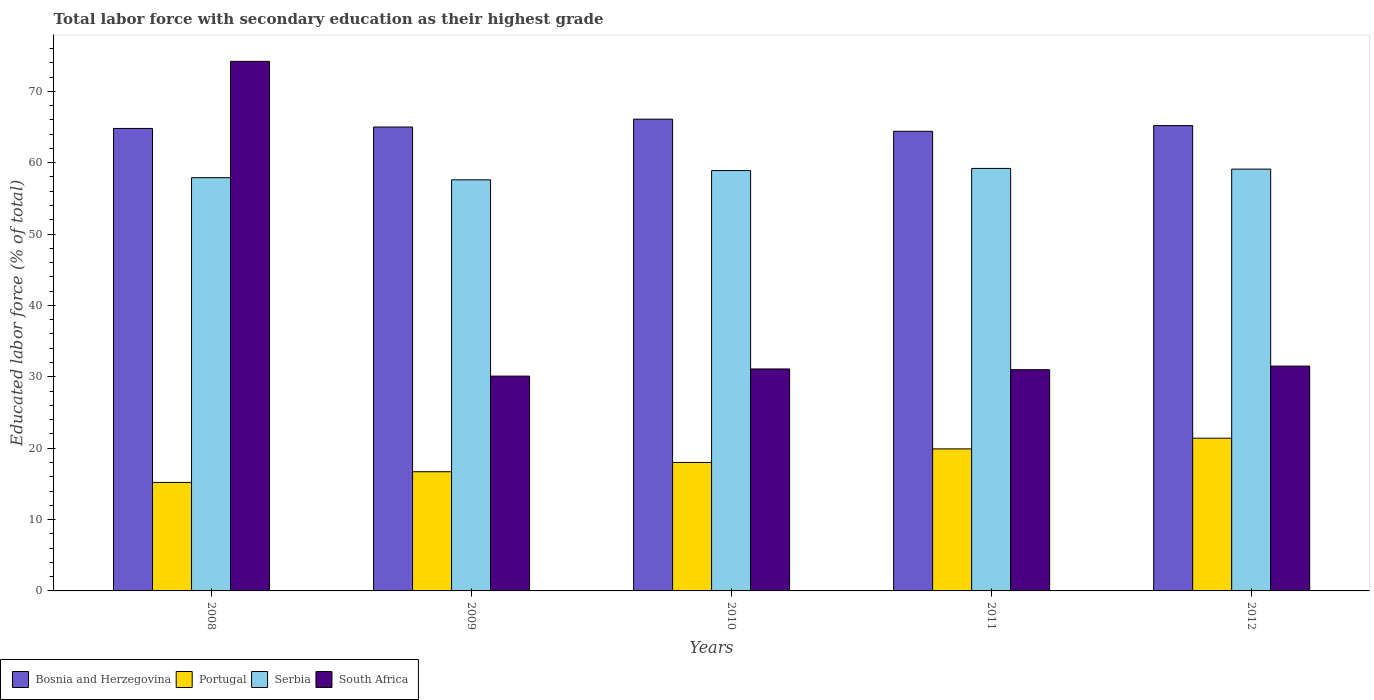Are the number of bars per tick equal to the number of legend labels?
Offer a terse response. Yes. How many bars are there on the 5th tick from the right?
Your response must be concise. 4. What is the percentage of total labor force with primary education in Bosnia and Herzegovina in 2009?
Make the answer very short. 65. Across all years, what is the maximum percentage of total labor force with primary education in Bosnia and Herzegovina?
Offer a very short reply. 66.1. Across all years, what is the minimum percentage of total labor force with primary education in South Africa?
Your answer should be very brief. 30.1. In which year was the percentage of total labor force with primary education in Bosnia and Herzegovina maximum?
Provide a short and direct response. 2010. In which year was the percentage of total labor force with primary education in Portugal minimum?
Keep it short and to the point. 2008. What is the total percentage of total labor force with primary education in Bosnia and Herzegovina in the graph?
Give a very brief answer. 325.5. What is the difference between the percentage of total labor force with primary education in Serbia in 2010 and that in 2011?
Provide a short and direct response. -0.3. What is the difference between the percentage of total labor force with primary education in Serbia in 2011 and the percentage of total labor force with primary education in South Africa in 2012?
Offer a very short reply. 27.7. What is the average percentage of total labor force with primary education in South Africa per year?
Give a very brief answer. 39.58. In the year 2011, what is the difference between the percentage of total labor force with primary education in South Africa and percentage of total labor force with primary education in Bosnia and Herzegovina?
Make the answer very short. -33.4. In how many years, is the percentage of total labor force with primary education in Serbia greater than 64 %?
Your response must be concise. 0. What is the ratio of the percentage of total labor force with primary education in Portugal in 2008 to that in 2010?
Make the answer very short. 0.84. Is the difference between the percentage of total labor force with primary education in South Africa in 2011 and 2012 greater than the difference between the percentage of total labor force with primary education in Bosnia and Herzegovina in 2011 and 2012?
Offer a terse response. Yes. What is the difference between the highest and the second highest percentage of total labor force with primary education in Bosnia and Herzegovina?
Provide a succinct answer. 0.9. What is the difference between the highest and the lowest percentage of total labor force with primary education in Bosnia and Herzegovina?
Provide a succinct answer. 1.7. In how many years, is the percentage of total labor force with primary education in Portugal greater than the average percentage of total labor force with primary education in Portugal taken over all years?
Provide a succinct answer. 2. Is it the case that in every year, the sum of the percentage of total labor force with primary education in Serbia and percentage of total labor force with primary education in Bosnia and Herzegovina is greater than the sum of percentage of total labor force with primary education in Portugal and percentage of total labor force with primary education in South Africa?
Provide a short and direct response. No. What does the 1st bar from the left in 2009 represents?
Provide a short and direct response. Bosnia and Herzegovina. What does the 2nd bar from the right in 2012 represents?
Give a very brief answer. Serbia. How many bars are there?
Your response must be concise. 20. Are the values on the major ticks of Y-axis written in scientific E-notation?
Provide a succinct answer. No. Does the graph contain any zero values?
Give a very brief answer. No. How many legend labels are there?
Offer a terse response. 4. What is the title of the graph?
Make the answer very short. Total labor force with secondary education as their highest grade. What is the label or title of the Y-axis?
Provide a succinct answer. Educated labor force (% of total). What is the Educated labor force (% of total) in Bosnia and Herzegovina in 2008?
Offer a terse response. 64.8. What is the Educated labor force (% of total) in Portugal in 2008?
Offer a very short reply. 15.2. What is the Educated labor force (% of total) of Serbia in 2008?
Your response must be concise. 57.9. What is the Educated labor force (% of total) in South Africa in 2008?
Ensure brevity in your answer.  74.2. What is the Educated labor force (% of total) of Portugal in 2009?
Offer a very short reply. 16.7. What is the Educated labor force (% of total) in Serbia in 2009?
Offer a terse response. 57.6. What is the Educated labor force (% of total) of South Africa in 2009?
Keep it short and to the point. 30.1. What is the Educated labor force (% of total) in Bosnia and Herzegovina in 2010?
Provide a succinct answer. 66.1. What is the Educated labor force (% of total) in Portugal in 2010?
Your answer should be very brief. 18. What is the Educated labor force (% of total) of Serbia in 2010?
Provide a short and direct response. 58.9. What is the Educated labor force (% of total) in South Africa in 2010?
Offer a very short reply. 31.1. What is the Educated labor force (% of total) in Bosnia and Herzegovina in 2011?
Offer a very short reply. 64.4. What is the Educated labor force (% of total) of Portugal in 2011?
Provide a succinct answer. 19.9. What is the Educated labor force (% of total) in Serbia in 2011?
Your response must be concise. 59.2. What is the Educated labor force (% of total) in South Africa in 2011?
Your answer should be very brief. 31. What is the Educated labor force (% of total) of Bosnia and Herzegovina in 2012?
Give a very brief answer. 65.2. What is the Educated labor force (% of total) of Portugal in 2012?
Give a very brief answer. 21.4. What is the Educated labor force (% of total) in Serbia in 2012?
Keep it short and to the point. 59.1. What is the Educated labor force (% of total) in South Africa in 2012?
Keep it short and to the point. 31.5. Across all years, what is the maximum Educated labor force (% of total) of Bosnia and Herzegovina?
Keep it short and to the point. 66.1. Across all years, what is the maximum Educated labor force (% of total) in Portugal?
Offer a very short reply. 21.4. Across all years, what is the maximum Educated labor force (% of total) in Serbia?
Your response must be concise. 59.2. Across all years, what is the maximum Educated labor force (% of total) of South Africa?
Your response must be concise. 74.2. Across all years, what is the minimum Educated labor force (% of total) in Bosnia and Herzegovina?
Offer a terse response. 64.4. Across all years, what is the minimum Educated labor force (% of total) in Portugal?
Offer a very short reply. 15.2. Across all years, what is the minimum Educated labor force (% of total) in Serbia?
Give a very brief answer. 57.6. Across all years, what is the minimum Educated labor force (% of total) of South Africa?
Give a very brief answer. 30.1. What is the total Educated labor force (% of total) in Bosnia and Herzegovina in the graph?
Provide a succinct answer. 325.5. What is the total Educated labor force (% of total) of Portugal in the graph?
Make the answer very short. 91.2. What is the total Educated labor force (% of total) of Serbia in the graph?
Your answer should be compact. 292.7. What is the total Educated labor force (% of total) in South Africa in the graph?
Your response must be concise. 197.9. What is the difference between the Educated labor force (% of total) of Bosnia and Herzegovina in 2008 and that in 2009?
Give a very brief answer. -0.2. What is the difference between the Educated labor force (% of total) in South Africa in 2008 and that in 2009?
Make the answer very short. 44.1. What is the difference between the Educated labor force (% of total) of Serbia in 2008 and that in 2010?
Offer a very short reply. -1. What is the difference between the Educated labor force (% of total) in South Africa in 2008 and that in 2010?
Your response must be concise. 43.1. What is the difference between the Educated labor force (% of total) in Serbia in 2008 and that in 2011?
Keep it short and to the point. -1.3. What is the difference between the Educated labor force (% of total) in South Africa in 2008 and that in 2011?
Give a very brief answer. 43.2. What is the difference between the Educated labor force (% of total) of Bosnia and Herzegovina in 2008 and that in 2012?
Keep it short and to the point. -0.4. What is the difference between the Educated labor force (% of total) in Serbia in 2008 and that in 2012?
Your answer should be compact. -1.2. What is the difference between the Educated labor force (% of total) of South Africa in 2008 and that in 2012?
Offer a very short reply. 42.7. What is the difference between the Educated labor force (% of total) in Portugal in 2009 and that in 2010?
Ensure brevity in your answer.  -1.3. What is the difference between the Educated labor force (% of total) in Serbia in 2009 and that in 2010?
Your answer should be very brief. -1.3. What is the difference between the Educated labor force (% of total) of South Africa in 2009 and that in 2010?
Ensure brevity in your answer.  -1. What is the difference between the Educated labor force (% of total) of South Africa in 2009 and that in 2011?
Your response must be concise. -0.9. What is the difference between the Educated labor force (% of total) in South Africa in 2009 and that in 2012?
Make the answer very short. -1.4. What is the difference between the Educated labor force (% of total) in Portugal in 2010 and that in 2011?
Provide a succinct answer. -1.9. What is the difference between the Educated labor force (% of total) of Serbia in 2010 and that in 2011?
Your answer should be compact. -0.3. What is the difference between the Educated labor force (% of total) of South Africa in 2010 and that in 2011?
Offer a very short reply. 0.1. What is the difference between the Educated labor force (% of total) of Bosnia and Herzegovina in 2010 and that in 2012?
Give a very brief answer. 0.9. What is the difference between the Educated labor force (% of total) in Portugal in 2010 and that in 2012?
Keep it short and to the point. -3.4. What is the difference between the Educated labor force (% of total) of South Africa in 2010 and that in 2012?
Ensure brevity in your answer.  -0.4. What is the difference between the Educated labor force (% of total) in Bosnia and Herzegovina in 2011 and that in 2012?
Keep it short and to the point. -0.8. What is the difference between the Educated labor force (% of total) in South Africa in 2011 and that in 2012?
Give a very brief answer. -0.5. What is the difference between the Educated labor force (% of total) in Bosnia and Herzegovina in 2008 and the Educated labor force (% of total) in Portugal in 2009?
Offer a very short reply. 48.1. What is the difference between the Educated labor force (% of total) of Bosnia and Herzegovina in 2008 and the Educated labor force (% of total) of South Africa in 2009?
Your answer should be compact. 34.7. What is the difference between the Educated labor force (% of total) in Portugal in 2008 and the Educated labor force (% of total) in Serbia in 2009?
Ensure brevity in your answer.  -42.4. What is the difference between the Educated labor force (% of total) in Portugal in 2008 and the Educated labor force (% of total) in South Africa in 2009?
Ensure brevity in your answer.  -14.9. What is the difference between the Educated labor force (% of total) in Serbia in 2008 and the Educated labor force (% of total) in South Africa in 2009?
Give a very brief answer. 27.8. What is the difference between the Educated labor force (% of total) in Bosnia and Herzegovina in 2008 and the Educated labor force (% of total) in Portugal in 2010?
Your answer should be compact. 46.8. What is the difference between the Educated labor force (% of total) of Bosnia and Herzegovina in 2008 and the Educated labor force (% of total) of Serbia in 2010?
Provide a succinct answer. 5.9. What is the difference between the Educated labor force (% of total) in Bosnia and Herzegovina in 2008 and the Educated labor force (% of total) in South Africa in 2010?
Your response must be concise. 33.7. What is the difference between the Educated labor force (% of total) of Portugal in 2008 and the Educated labor force (% of total) of Serbia in 2010?
Provide a short and direct response. -43.7. What is the difference between the Educated labor force (% of total) of Portugal in 2008 and the Educated labor force (% of total) of South Africa in 2010?
Offer a terse response. -15.9. What is the difference between the Educated labor force (% of total) of Serbia in 2008 and the Educated labor force (% of total) of South Africa in 2010?
Give a very brief answer. 26.8. What is the difference between the Educated labor force (% of total) in Bosnia and Herzegovina in 2008 and the Educated labor force (% of total) in Portugal in 2011?
Ensure brevity in your answer.  44.9. What is the difference between the Educated labor force (% of total) in Bosnia and Herzegovina in 2008 and the Educated labor force (% of total) in South Africa in 2011?
Offer a very short reply. 33.8. What is the difference between the Educated labor force (% of total) of Portugal in 2008 and the Educated labor force (% of total) of Serbia in 2011?
Your answer should be compact. -44. What is the difference between the Educated labor force (% of total) in Portugal in 2008 and the Educated labor force (% of total) in South Africa in 2011?
Offer a very short reply. -15.8. What is the difference between the Educated labor force (% of total) of Serbia in 2008 and the Educated labor force (% of total) of South Africa in 2011?
Keep it short and to the point. 26.9. What is the difference between the Educated labor force (% of total) in Bosnia and Herzegovina in 2008 and the Educated labor force (% of total) in Portugal in 2012?
Offer a very short reply. 43.4. What is the difference between the Educated labor force (% of total) in Bosnia and Herzegovina in 2008 and the Educated labor force (% of total) in Serbia in 2012?
Offer a terse response. 5.7. What is the difference between the Educated labor force (% of total) in Bosnia and Herzegovina in 2008 and the Educated labor force (% of total) in South Africa in 2012?
Your answer should be very brief. 33.3. What is the difference between the Educated labor force (% of total) in Portugal in 2008 and the Educated labor force (% of total) in Serbia in 2012?
Your answer should be compact. -43.9. What is the difference between the Educated labor force (% of total) of Portugal in 2008 and the Educated labor force (% of total) of South Africa in 2012?
Make the answer very short. -16.3. What is the difference between the Educated labor force (% of total) of Serbia in 2008 and the Educated labor force (% of total) of South Africa in 2012?
Your response must be concise. 26.4. What is the difference between the Educated labor force (% of total) in Bosnia and Herzegovina in 2009 and the Educated labor force (% of total) in Serbia in 2010?
Make the answer very short. 6.1. What is the difference between the Educated labor force (% of total) of Bosnia and Herzegovina in 2009 and the Educated labor force (% of total) of South Africa in 2010?
Your response must be concise. 33.9. What is the difference between the Educated labor force (% of total) in Portugal in 2009 and the Educated labor force (% of total) in Serbia in 2010?
Make the answer very short. -42.2. What is the difference between the Educated labor force (% of total) in Portugal in 2009 and the Educated labor force (% of total) in South Africa in 2010?
Keep it short and to the point. -14.4. What is the difference between the Educated labor force (% of total) of Bosnia and Herzegovina in 2009 and the Educated labor force (% of total) of Portugal in 2011?
Offer a terse response. 45.1. What is the difference between the Educated labor force (% of total) of Bosnia and Herzegovina in 2009 and the Educated labor force (% of total) of Serbia in 2011?
Keep it short and to the point. 5.8. What is the difference between the Educated labor force (% of total) of Bosnia and Herzegovina in 2009 and the Educated labor force (% of total) of South Africa in 2011?
Ensure brevity in your answer.  34. What is the difference between the Educated labor force (% of total) of Portugal in 2009 and the Educated labor force (% of total) of Serbia in 2011?
Your response must be concise. -42.5. What is the difference between the Educated labor force (% of total) of Portugal in 2009 and the Educated labor force (% of total) of South Africa in 2011?
Your answer should be very brief. -14.3. What is the difference between the Educated labor force (% of total) of Serbia in 2009 and the Educated labor force (% of total) of South Africa in 2011?
Keep it short and to the point. 26.6. What is the difference between the Educated labor force (% of total) of Bosnia and Herzegovina in 2009 and the Educated labor force (% of total) of Portugal in 2012?
Make the answer very short. 43.6. What is the difference between the Educated labor force (% of total) in Bosnia and Herzegovina in 2009 and the Educated labor force (% of total) in Serbia in 2012?
Make the answer very short. 5.9. What is the difference between the Educated labor force (% of total) in Bosnia and Herzegovina in 2009 and the Educated labor force (% of total) in South Africa in 2012?
Offer a terse response. 33.5. What is the difference between the Educated labor force (% of total) in Portugal in 2009 and the Educated labor force (% of total) in Serbia in 2012?
Provide a short and direct response. -42.4. What is the difference between the Educated labor force (% of total) of Portugal in 2009 and the Educated labor force (% of total) of South Africa in 2012?
Keep it short and to the point. -14.8. What is the difference between the Educated labor force (% of total) in Serbia in 2009 and the Educated labor force (% of total) in South Africa in 2012?
Offer a terse response. 26.1. What is the difference between the Educated labor force (% of total) of Bosnia and Herzegovina in 2010 and the Educated labor force (% of total) of Portugal in 2011?
Make the answer very short. 46.2. What is the difference between the Educated labor force (% of total) in Bosnia and Herzegovina in 2010 and the Educated labor force (% of total) in Serbia in 2011?
Offer a terse response. 6.9. What is the difference between the Educated labor force (% of total) of Bosnia and Herzegovina in 2010 and the Educated labor force (% of total) of South Africa in 2011?
Give a very brief answer. 35.1. What is the difference between the Educated labor force (% of total) of Portugal in 2010 and the Educated labor force (% of total) of Serbia in 2011?
Your answer should be very brief. -41.2. What is the difference between the Educated labor force (% of total) of Serbia in 2010 and the Educated labor force (% of total) of South Africa in 2011?
Provide a succinct answer. 27.9. What is the difference between the Educated labor force (% of total) of Bosnia and Herzegovina in 2010 and the Educated labor force (% of total) of Portugal in 2012?
Your answer should be very brief. 44.7. What is the difference between the Educated labor force (% of total) of Bosnia and Herzegovina in 2010 and the Educated labor force (% of total) of South Africa in 2012?
Provide a short and direct response. 34.6. What is the difference between the Educated labor force (% of total) of Portugal in 2010 and the Educated labor force (% of total) of Serbia in 2012?
Give a very brief answer. -41.1. What is the difference between the Educated labor force (% of total) in Portugal in 2010 and the Educated labor force (% of total) in South Africa in 2012?
Make the answer very short. -13.5. What is the difference between the Educated labor force (% of total) of Serbia in 2010 and the Educated labor force (% of total) of South Africa in 2012?
Offer a terse response. 27.4. What is the difference between the Educated labor force (% of total) in Bosnia and Herzegovina in 2011 and the Educated labor force (% of total) in South Africa in 2012?
Your response must be concise. 32.9. What is the difference between the Educated labor force (% of total) in Portugal in 2011 and the Educated labor force (% of total) in Serbia in 2012?
Offer a terse response. -39.2. What is the difference between the Educated labor force (% of total) in Serbia in 2011 and the Educated labor force (% of total) in South Africa in 2012?
Your answer should be compact. 27.7. What is the average Educated labor force (% of total) of Bosnia and Herzegovina per year?
Ensure brevity in your answer.  65.1. What is the average Educated labor force (% of total) in Portugal per year?
Provide a succinct answer. 18.24. What is the average Educated labor force (% of total) of Serbia per year?
Provide a succinct answer. 58.54. What is the average Educated labor force (% of total) in South Africa per year?
Your answer should be very brief. 39.58. In the year 2008, what is the difference between the Educated labor force (% of total) in Bosnia and Herzegovina and Educated labor force (% of total) in Portugal?
Offer a terse response. 49.6. In the year 2008, what is the difference between the Educated labor force (% of total) of Bosnia and Herzegovina and Educated labor force (% of total) of Serbia?
Your answer should be compact. 6.9. In the year 2008, what is the difference between the Educated labor force (% of total) in Bosnia and Herzegovina and Educated labor force (% of total) in South Africa?
Your response must be concise. -9.4. In the year 2008, what is the difference between the Educated labor force (% of total) in Portugal and Educated labor force (% of total) in Serbia?
Give a very brief answer. -42.7. In the year 2008, what is the difference between the Educated labor force (% of total) of Portugal and Educated labor force (% of total) of South Africa?
Your answer should be compact. -59. In the year 2008, what is the difference between the Educated labor force (% of total) in Serbia and Educated labor force (% of total) in South Africa?
Your answer should be compact. -16.3. In the year 2009, what is the difference between the Educated labor force (% of total) in Bosnia and Herzegovina and Educated labor force (% of total) in Portugal?
Your response must be concise. 48.3. In the year 2009, what is the difference between the Educated labor force (% of total) in Bosnia and Herzegovina and Educated labor force (% of total) in South Africa?
Keep it short and to the point. 34.9. In the year 2009, what is the difference between the Educated labor force (% of total) of Portugal and Educated labor force (% of total) of Serbia?
Ensure brevity in your answer.  -40.9. In the year 2009, what is the difference between the Educated labor force (% of total) in Serbia and Educated labor force (% of total) in South Africa?
Keep it short and to the point. 27.5. In the year 2010, what is the difference between the Educated labor force (% of total) of Bosnia and Herzegovina and Educated labor force (% of total) of Portugal?
Your answer should be very brief. 48.1. In the year 2010, what is the difference between the Educated labor force (% of total) in Bosnia and Herzegovina and Educated labor force (% of total) in Serbia?
Provide a short and direct response. 7.2. In the year 2010, what is the difference between the Educated labor force (% of total) of Portugal and Educated labor force (% of total) of Serbia?
Your response must be concise. -40.9. In the year 2010, what is the difference between the Educated labor force (% of total) in Serbia and Educated labor force (% of total) in South Africa?
Offer a terse response. 27.8. In the year 2011, what is the difference between the Educated labor force (% of total) of Bosnia and Herzegovina and Educated labor force (% of total) of Portugal?
Keep it short and to the point. 44.5. In the year 2011, what is the difference between the Educated labor force (% of total) of Bosnia and Herzegovina and Educated labor force (% of total) of Serbia?
Your answer should be very brief. 5.2. In the year 2011, what is the difference between the Educated labor force (% of total) in Bosnia and Herzegovina and Educated labor force (% of total) in South Africa?
Offer a terse response. 33.4. In the year 2011, what is the difference between the Educated labor force (% of total) of Portugal and Educated labor force (% of total) of Serbia?
Ensure brevity in your answer.  -39.3. In the year 2011, what is the difference between the Educated labor force (% of total) in Serbia and Educated labor force (% of total) in South Africa?
Provide a short and direct response. 28.2. In the year 2012, what is the difference between the Educated labor force (% of total) in Bosnia and Herzegovina and Educated labor force (% of total) in Portugal?
Keep it short and to the point. 43.8. In the year 2012, what is the difference between the Educated labor force (% of total) of Bosnia and Herzegovina and Educated labor force (% of total) of Serbia?
Provide a short and direct response. 6.1. In the year 2012, what is the difference between the Educated labor force (% of total) in Bosnia and Herzegovina and Educated labor force (% of total) in South Africa?
Give a very brief answer. 33.7. In the year 2012, what is the difference between the Educated labor force (% of total) in Portugal and Educated labor force (% of total) in Serbia?
Keep it short and to the point. -37.7. In the year 2012, what is the difference between the Educated labor force (% of total) in Serbia and Educated labor force (% of total) in South Africa?
Make the answer very short. 27.6. What is the ratio of the Educated labor force (% of total) in Bosnia and Herzegovina in 2008 to that in 2009?
Your answer should be very brief. 1. What is the ratio of the Educated labor force (% of total) of Portugal in 2008 to that in 2009?
Ensure brevity in your answer.  0.91. What is the ratio of the Educated labor force (% of total) of South Africa in 2008 to that in 2009?
Your response must be concise. 2.47. What is the ratio of the Educated labor force (% of total) of Bosnia and Herzegovina in 2008 to that in 2010?
Offer a very short reply. 0.98. What is the ratio of the Educated labor force (% of total) in Portugal in 2008 to that in 2010?
Your answer should be very brief. 0.84. What is the ratio of the Educated labor force (% of total) of South Africa in 2008 to that in 2010?
Make the answer very short. 2.39. What is the ratio of the Educated labor force (% of total) in Bosnia and Herzegovina in 2008 to that in 2011?
Offer a terse response. 1.01. What is the ratio of the Educated labor force (% of total) of Portugal in 2008 to that in 2011?
Make the answer very short. 0.76. What is the ratio of the Educated labor force (% of total) of South Africa in 2008 to that in 2011?
Ensure brevity in your answer.  2.39. What is the ratio of the Educated labor force (% of total) of Portugal in 2008 to that in 2012?
Provide a succinct answer. 0.71. What is the ratio of the Educated labor force (% of total) in Serbia in 2008 to that in 2012?
Your response must be concise. 0.98. What is the ratio of the Educated labor force (% of total) of South Africa in 2008 to that in 2012?
Your response must be concise. 2.36. What is the ratio of the Educated labor force (% of total) of Bosnia and Herzegovina in 2009 to that in 2010?
Your answer should be compact. 0.98. What is the ratio of the Educated labor force (% of total) of Portugal in 2009 to that in 2010?
Offer a terse response. 0.93. What is the ratio of the Educated labor force (% of total) of Serbia in 2009 to that in 2010?
Give a very brief answer. 0.98. What is the ratio of the Educated labor force (% of total) in South Africa in 2009 to that in 2010?
Give a very brief answer. 0.97. What is the ratio of the Educated labor force (% of total) in Bosnia and Herzegovina in 2009 to that in 2011?
Give a very brief answer. 1.01. What is the ratio of the Educated labor force (% of total) of Portugal in 2009 to that in 2011?
Offer a terse response. 0.84. What is the ratio of the Educated labor force (% of total) of Serbia in 2009 to that in 2011?
Your answer should be very brief. 0.97. What is the ratio of the Educated labor force (% of total) of Portugal in 2009 to that in 2012?
Offer a very short reply. 0.78. What is the ratio of the Educated labor force (% of total) in Serbia in 2009 to that in 2012?
Make the answer very short. 0.97. What is the ratio of the Educated labor force (% of total) in South Africa in 2009 to that in 2012?
Your answer should be compact. 0.96. What is the ratio of the Educated labor force (% of total) in Bosnia and Herzegovina in 2010 to that in 2011?
Your answer should be compact. 1.03. What is the ratio of the Educated labor force (% of total) in Portugal in 2010 to that in 2011?
Offer a very short reply. 0.9. What is the ratio of the Educated labor force (% of total) of Serbia in 2010 to that in 2011?
Provide a short and direct response. 0.99. What is the ratio of the Educated labor force (% of total) in Bosnia and Herzegovina in 2010 to that in 2012?
Give a very brief answer. 1.01. What is the ratio of the Educated labor force (% of total) of Portugal in 2010 to that in 2012?
Keep it short and to the point. 0.84. What is the ratio of the Educated labor force (% of total) in South Africa in 2010 to that in 2012?
Ensure brevity in your answer.  0.99. What is the ratio of the Educated labor force (% of total) in Bosnia and Herzegovina in 2011 to that in 2012?
Provide a succinct answer. 0.99. What is the ratio of the Educated labor force (% of total) of Portugal in 2011 to that in 2012?
Provide a succinct answer. 0.93. What is the ratio of the Educated labor force (% of total) in Serbia in 2011 to that in 2012?
Provide a succinct answer. 1. What is the ratio of the Educated labor force (% of total) of South Africa in 2011 to that in 2012?
Ensure brevity in your answer.  0.98. What is the difference between the highest and the second highest Educated labor force (% of total) in Serbia?
Your response must be concise. 0.1. What is the difference between the highest and the second highest Educated labor force (% of total) of South Africa?
Your answer should be compact. 42.7. What is the difference between the highest and the lowest Educated labor force (% of total) in Bosnia and Herzegovina?
Provide a short and direct response. 1.7. What is the difference between the highest and the lowest Educated labor force (% of total) in Portugal?
Your answer should be compact. 6.2. What is the difference between the highest and the lowest Educated labor force (% of total) of Serbia?
Offer a terse response. 1.6. What is the difference between the highest and the lowest Educated labor force (% of total) in South Africa?
Provide a short and direct response. 44.1. 